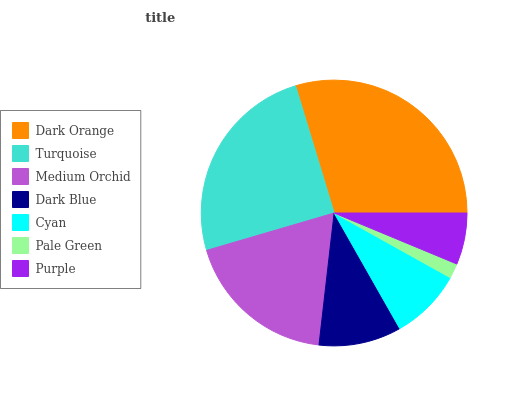Is Pale Green the minimum?
Answer yes or no. Yes. Is Dark Orange the maximum?
Answer yes or no. Yes. Is Turquoise the minimum?
Answer yes or no. No. Is Turquoise the maximum?
Answer yes or no. No. Is Dark Orange greater than Turquoise?
Answer yes or no. Yes. Is Turquoise less than Dark Orange?
Answer yes or no. Yes. Is Turquoise greater than Dark Orange?
Answer yes or no. No. Is Dark Orange less than Turquoise?
Answer yes or no. No. Is Dark Blue the high median?
Answer yes or no. Yes. Is Dark Blue the low median?
Answer yes or no. Yes. Is Purple the high median?
Answer yes or no. No. Is Medium Orchid the low median?
Answer yes or no. No. 